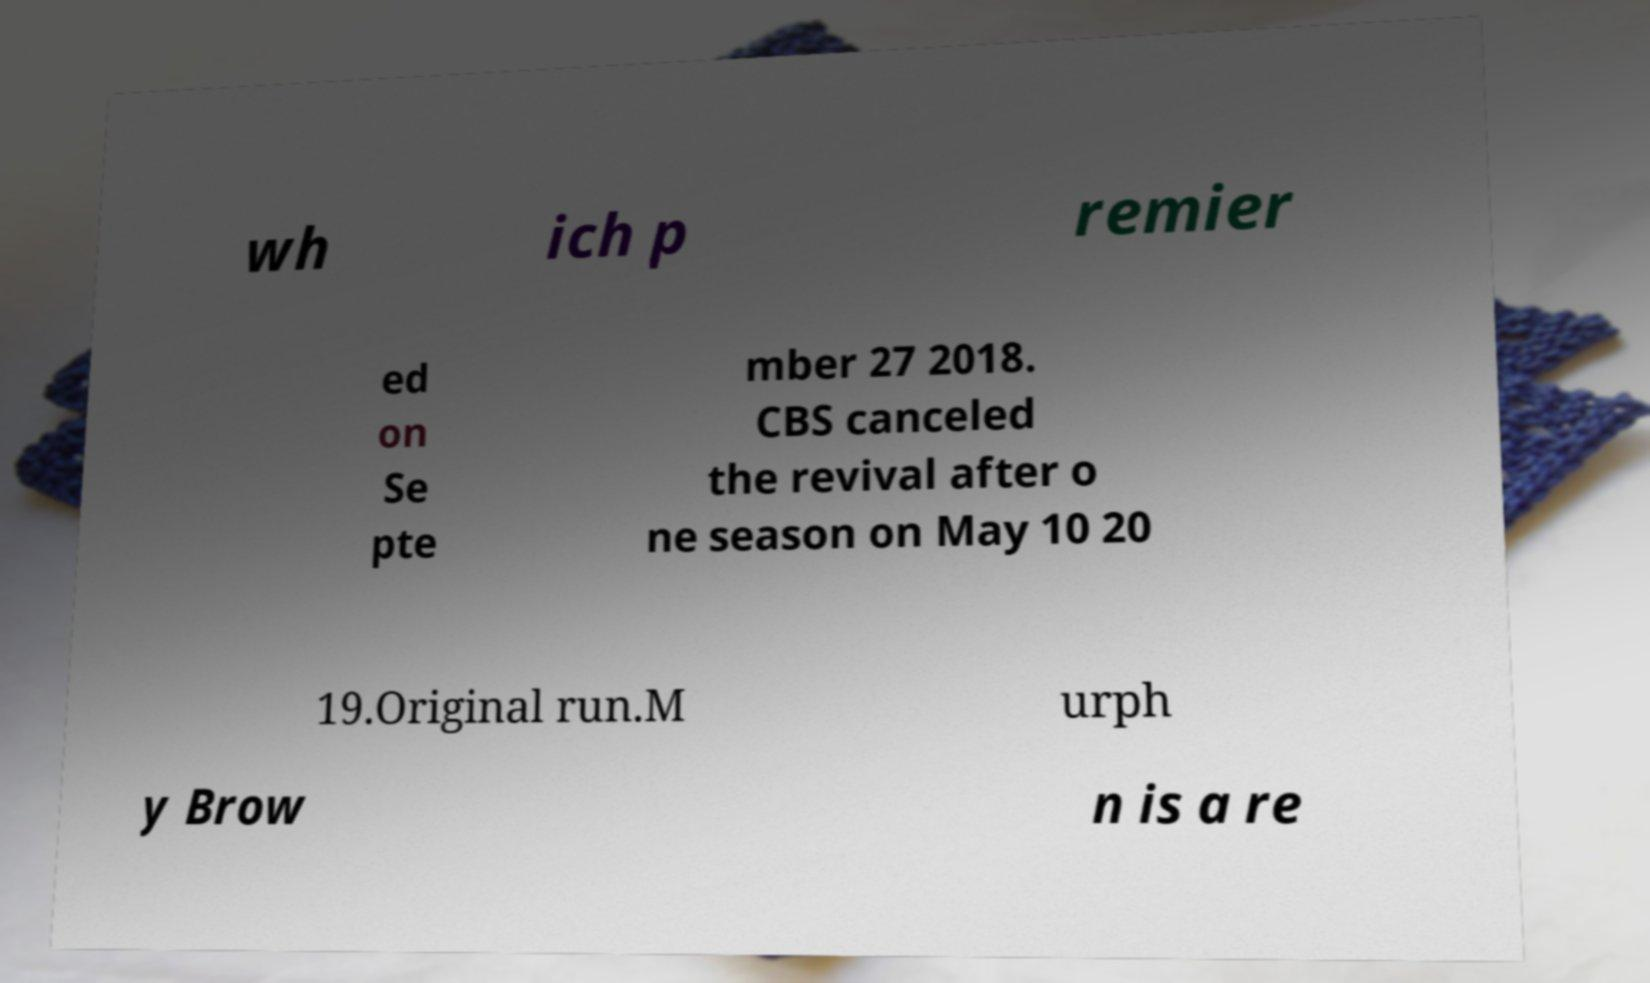For documentation purposes, I need the text within this image transcribed. Could you provide that? wh ich p remier ed on Se pte mber 27 2018. CBS canceled the revival after o ne season on May 10 20 19.Original run.M urph y Brow n is a re 